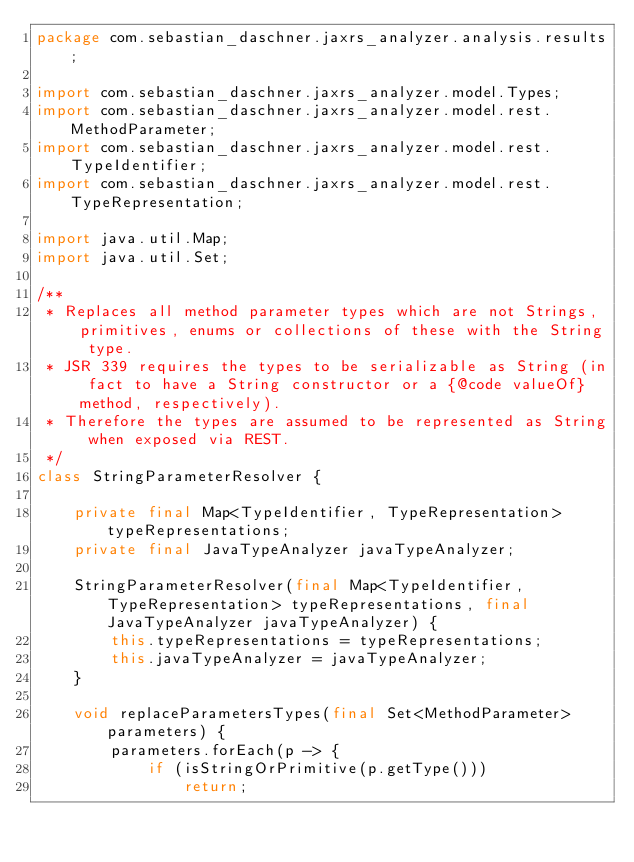Convert code to text. <code><loc_0><loc_0><loc_500><loc_500><_Java_>package com.sebastian_daschner.jaxrs_analyzer.analysis.results;

import com.sebastian_daschner.jaxrs_analyzer.model.Types;
import com.sebastian_daschner.jaxrs_analyzer.model.rest.MethodParameter;
import com.sebastian_daschner.jaxrs_analyzer.model.rest.TypeIdentifier;
import com.sebastian_daschner.jaxrs_analyzer.model.rest.TypeRepresentation;

import java.util.Map;
import java.util.Set;

/**
 * Replaces all method parameter types which are not Strings, primitives, enums or collections of these with the String type.
 * JSR 339 requires the types to be serializable as String (in fact to have a String constructor or a {@code valueOf} method, respectively).
 * Therefore the types are assumed to be represented as String when exposed via REST.
 */
class StringParameterResolver {

    private final Map<TypeIdentifier, TypeRepresentation> typeRepresentations;
    private final JavaTypeAnalyzer javaTypeAnalyzer;

    StringParameterResolver(final Map<TypeIdentifier, TypeRepresentation> typeRepresentations, final JavaTypeAnalyzer javaTypeAnalyzer) {
        this.typeRepresentations = typeRepresentations;
        this.javaTypeAnalyzer = javaTypeAnalyzer;
    }

    void replaceParametersTypes(final Set<MethodParameter> parameters) {
        parameters.forEach(p -> {
            if (isStringOrPrimitive(p.getType()))
                return;
</code> 